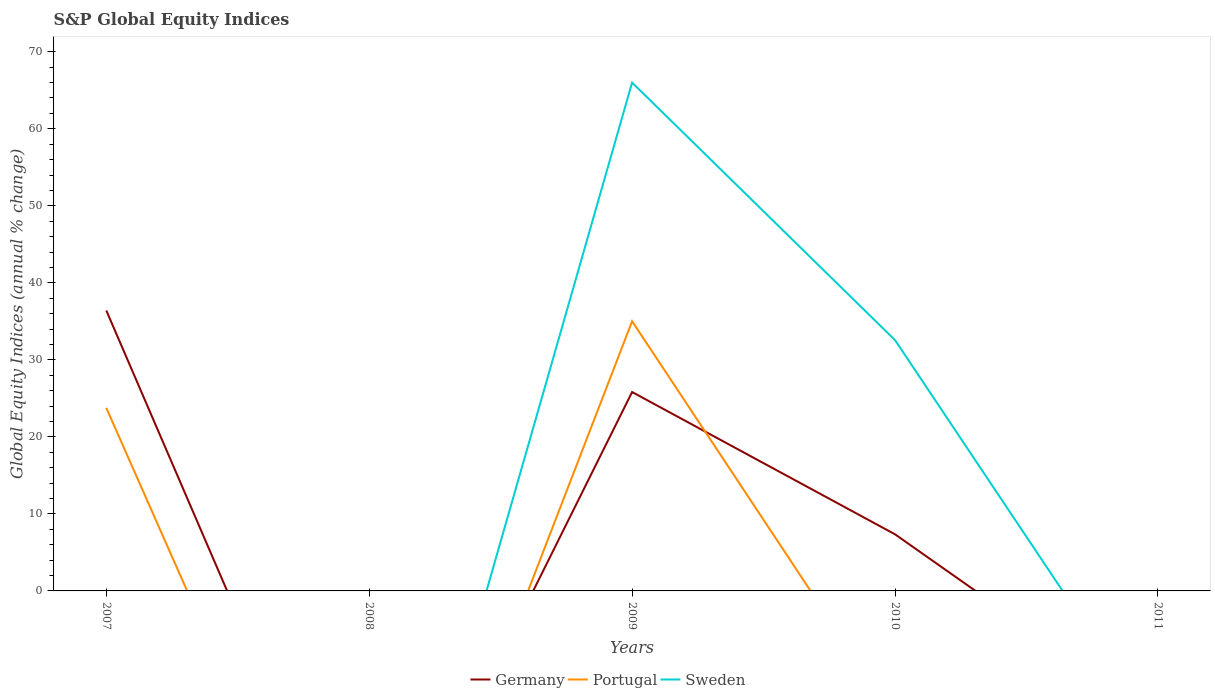Does the line corresponding to Germany intersect with the line corresponding to Sweden?
Ensure brevity in your answer.  Yes. What is the total global equity indices in Sweden in the graph?
Provide a succinct answer. 33.44. What is the difference between the highest and the second highest global equity indices in Germany?
Offer a very short reply. 36.41. What is the difference between the highest and the lowest global equity indices in Germany?
Give a very brief answer. 2. Is the global equity indices in Portugal strictly greater than the global equity indices in Germany over the years?
Offer a very short reply. No. How many years are there in the graph?
Your answer should be compact. 5. Are the values on the major ticks of Y-axis written in scientific E-notation?
Offer a very short reply. No. Does the graph contain any zero values?
Ensure brevity in your answer.  Yes. Does the graph contain grids?
Ensure brevity in your answer.  No. Where does the legend appear in the graph?
Ensure brevity in your answer.  Bottom center. What is the title of the graph?
Ensure brevity in your answer.  S&P Global Equity Indices. Does "Malta" appear as one of the legend labels in the graph?
Make the answer very short. No. What is the label or title of the Y-axis?
Make the answer very short. Global Equity Indices (annual % change). What is the Global Equity Indices (annual % change) of Germany in 2007?
Your answer should be very brief. 36.41. What is the Global Equity Indices (annual % change) of Portugal in 2007?
Your answer should be compact. 23.76. What is the Global Equity Indices (annual % change) of Sweden in 2007?
Your answer should be very brief. 0. What is the Global Equity Indices (annual % change) of Germany in 2009?
Provide a short and direct response. 25.82. What is the Global Equity Indices (annual % change) in Portugal in 2009?
Your answer should be very brief. 35.02. What is the Global Equity Indices (annual % change) of Sweden in 2009?
Ensure brevity in your answer.  66. What is the Global Equity Indices (annual % change) of Germany in 2010?
Offer a terse response. 7.35. What is the Global Equity Indices (annual % change) in Portugal in 2010?
Provide a succinct answer. 0. What is the Global Equity Indices (annual % change) of Sweden in 2010?
Offer a terse response. 32.56. What is the Global Equity Indices (annual % change) of Sweden in 2011?
Offer a terse response. 0. Across all years, what is the maximum Global Equity Indices (annual % change) in Germany?
Your response must be concise. 36.41. Across all years, what is the maximum Global Equity Indices (annual % change) of Portugal?
Ensure brevity in your answer.  35.02. Across all years, what is the maximum Global Equity Indices (annual % change) of Sweden?
Offer a very short reply. 66. Across all years, what is the minimum Global Equity Indices (annual % change) of Portugal?
Ensure brevity in your answer.  0. What is the total Global Equity Indices (annual % change) of Germany in the graph?
Make the answer very short. 69.59. What is the total Global Equity Indices (annual % change) of Portugal in the graph?
Your answer should be very brief. 58.78. What is the total Global Equity Indices (annual % change) of Sweden in the graph?
Your response must be concise. 98.56. What is the difference between the Global Equity Indices (annual % change) in Germany in 2007 and that in 2009?
Provide a short and direct response. 10.59. What is the difference between the Global Equity Indices (annual % change) of Portugal in 2007 and that in 2009?
Your answer should be compact. -11.26. What is the difference between the Global Equity Indices (annual % change) of Germany in 2007 and that in 2010?
Provide a succinct answer. 29.06. What is the difference between the Global Equity Indices (annual % change) in Germany in 2009 and that in 2010?
Make the answer very short. 18.47. What is the difference between the Global Equity Indices (annual % change) of Sweden in 2009 and that in 2010?
Provide a succinct answer. 33.44. What is the difference between the Global Equity Indices (annual % change) in Germany in 2007 and the Global Equity Indices (annual % change) in Portugal in 2009?
Make the answer very short. 1.39. What is the difference between the Global Equity Indices (annual % change) of Germany in 2007 and the Global Equity Indices (annual % change) of Sweden in 2009?
Your answer should be very brief. -29.59. What is the difference between the Global Equity Indices (annual % change) of Portugal in 2007 and the Global Equity Indices (annual % change) of Sweden in 2009?
Your answer should be compact. -42.24. What is the difference between the Global Equity Indices (annual % change) in Germany in 2007 and the Global Equity Indices (annual % change) in Sweden in 2010?
Provide a short and direct response. 3.85. What is the difference between the Global Equity Indices (annual % change) of Portugal in 2007 and the Global Equity Indices (annual % change) of Sweden in 2010?
Provide a short and direct response. -8.8. What is the difference between the Global Equity Indices (annual % change) in Germany in 2009 and the Global Equity Indices (annual % change) in Sweden in 2010?
Give a very brief answer. -6.74. What is the difference between the Global Equity Indices (annual % change) of Portugal in 2009 and the Global Equity Indices (annual % change) of Sweden in 2010?
Give a very brief answer. 2.45. What is the average Global Equity Indices (annual % change) of Germany per year?
Provide a succinct answer. 13.92. What is the average Global Equity Indices (annual % change) in Portugal per year?
Give a very brief answer. 11.76. What is the average Global Equity Indices (annual % change) of Sweden per year?
Provide a short and direct response. 19.71. In the year 2007, what is the difference between the Global Equity Indices (annual % change) in Germany and Global Equity Indices (annual % change) in Portugal?
Ensure brevity in your answer.  12.65. In the year 2009, what is the difference between the Global Equity Indices (annual % change) in Germany and Global Equity Indices (annual % change) in Portugal?
Keep it short and to the point. -9.19. In the year 2009, what is the difference between the Global Equity Indices (annual % change) of Germany and Global Equity Indices (annual % change) of Sweden?
Your answer should be very brief. -40.18. In the year 2009, what is the difference between the Global Equity Indices (annual % change) of Portugal and Global Equity Indices (annual % change) of Sweden?
Make the answer very short. -30.98. In the year 2010, what is the difference between the Global Equity Indices (annual % change) of Germany and Global Equity Indices (annual % change) of Sweden?
Make the answer very short. -25.21. What is the ratio of the Global Equity Indices (annual % change) in Germany in 2007 to that in 2009?
Offer a terse response. 1.41. What is the ratio of the Global Equity Indices (annual % change) in Portugal in 2007 to that in 2009?
Give a very brief answer. 0.68. What is the ratio of the Global Equity Indices (annual % change) in Germany in 2007 to that in 2010?
Give a very brief answer. 4.95. What is the ratio of the Global Equity Indices (annual % change) in Germany in 2009 to that in 2010?
Provide a short and direct response. 3.51. What is the ratio of the Global Equity Indices (annual % change) in Sweden in 2009 to that in 2010?
Give a very brief answer. 2.03. What is the difference between the highest and the second highest Global Equity Indices (annual % change) in Germany?
Your answer should be very brief. 10.59. What is the difference between the highest and the lowest Global Equity Indices (annual % change) in Germany?
Provide a short and direct response. 36.41. What is the difference between the highest and the lowest Global Equity Indices (annual % change) of Portugal?
Give a very brief answer. 35.02. What is the difference between the highest and the lowest Global Equity Indices (annual % change) of Sweden?
Keep it short and to the point. 66. 